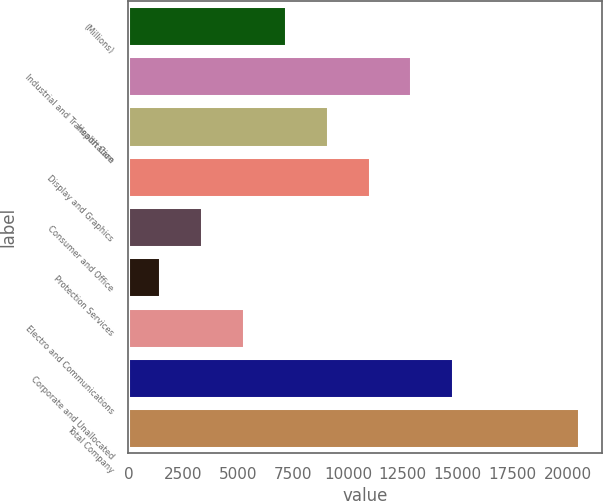Convert chart. <chart><loc_0><loc_0><loc_500><loc_500><bar_chart><fcel>(Millions)<fcel>Industrial and Transportation<fcel>Health Care<fcel>Display and Graphics<fcel>Consumer and Office<fcel>Protection Services<fcel>Electro and Communications<fcel>Corporate and Unallocated<fcel>Total Company<nl><fcel>7162.6<fcel>12896.2<fcel>9073.8<fcel>10985<fcel>3340.2<fcel>1429<fcel>5251.4<fcel>14807.4<fcel>20541<nl></chart> 